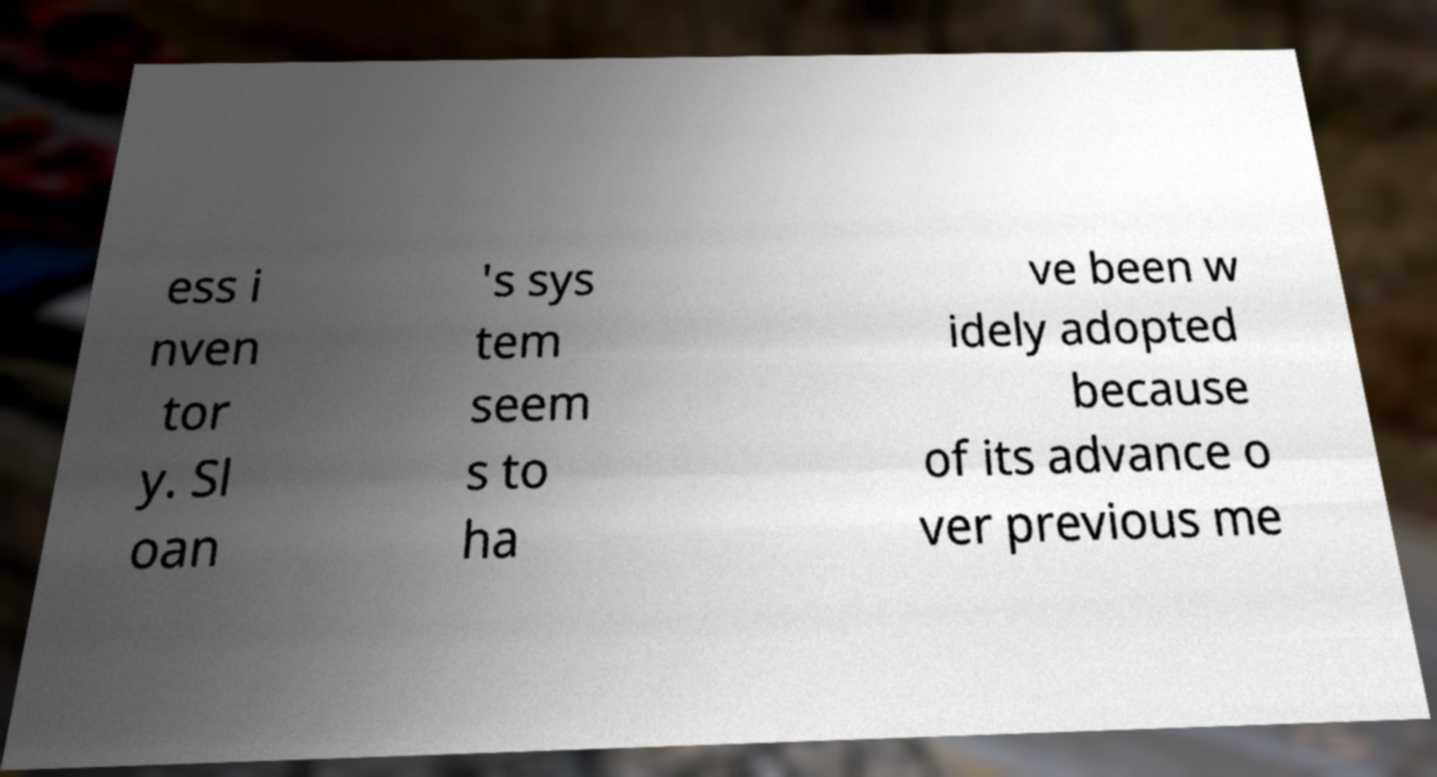There's text embedded in this image that I need extracted. Can you transcribe it verbatim? ess i nven tor y. Sl oan 's sys tem seem s to ha ve been w idely adopted because of its advance o ver previous me 